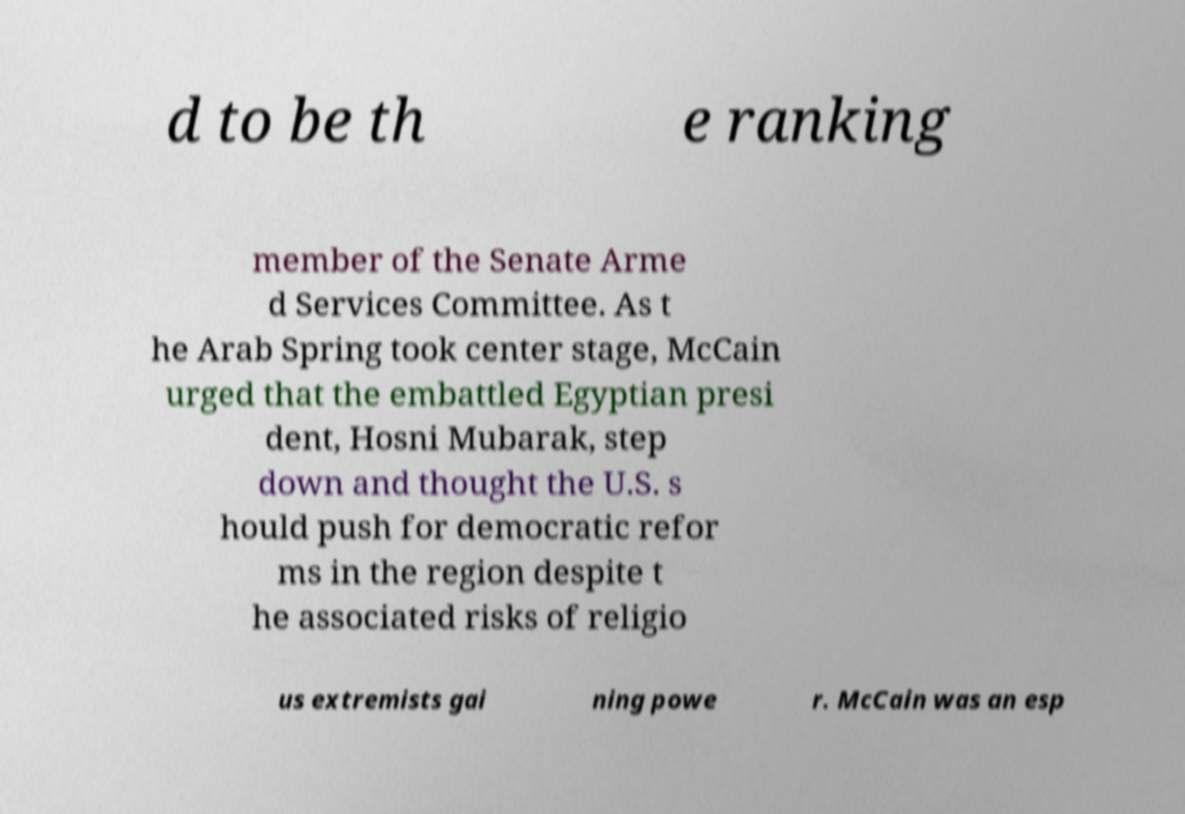For documentation purposes, I need the text within this image transcribed. Could you provide that? d to be th e ranking member of the Senate Arme d Services Committee. As t he Arab Spring took center stage, McCain urged that the embattled Egyptian presi dent, Hosni Mubarak, step down and thought the U.S. s hould push for democratic refor ms in the region despite t he associated risks of religio us extremists gai ning powe r. McCain was an esp 